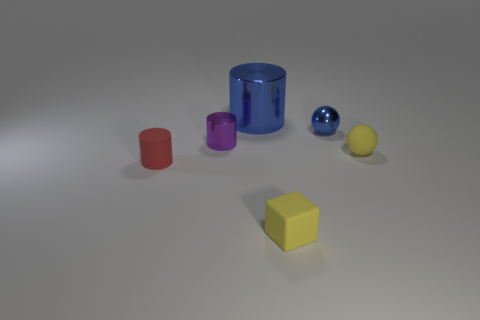Subtract all cyan spheres. Subtract all red blocks. How many spheres are left? 2 Add 3 matte spheres. How many objects exist? 9 Subtract all cubes. How many objects are left? 5 Add 3 blue metal cylinders. How many blue metal cylinders exist? 4 Subtract 0 brown blocks. How many objects are left? 6 Subtract all small purple things. Subtract all tiny yellow matte blocks. How many objects are left? 4 Add 5 large blue metallic objects. How many large blue metallic objects are left? 6 